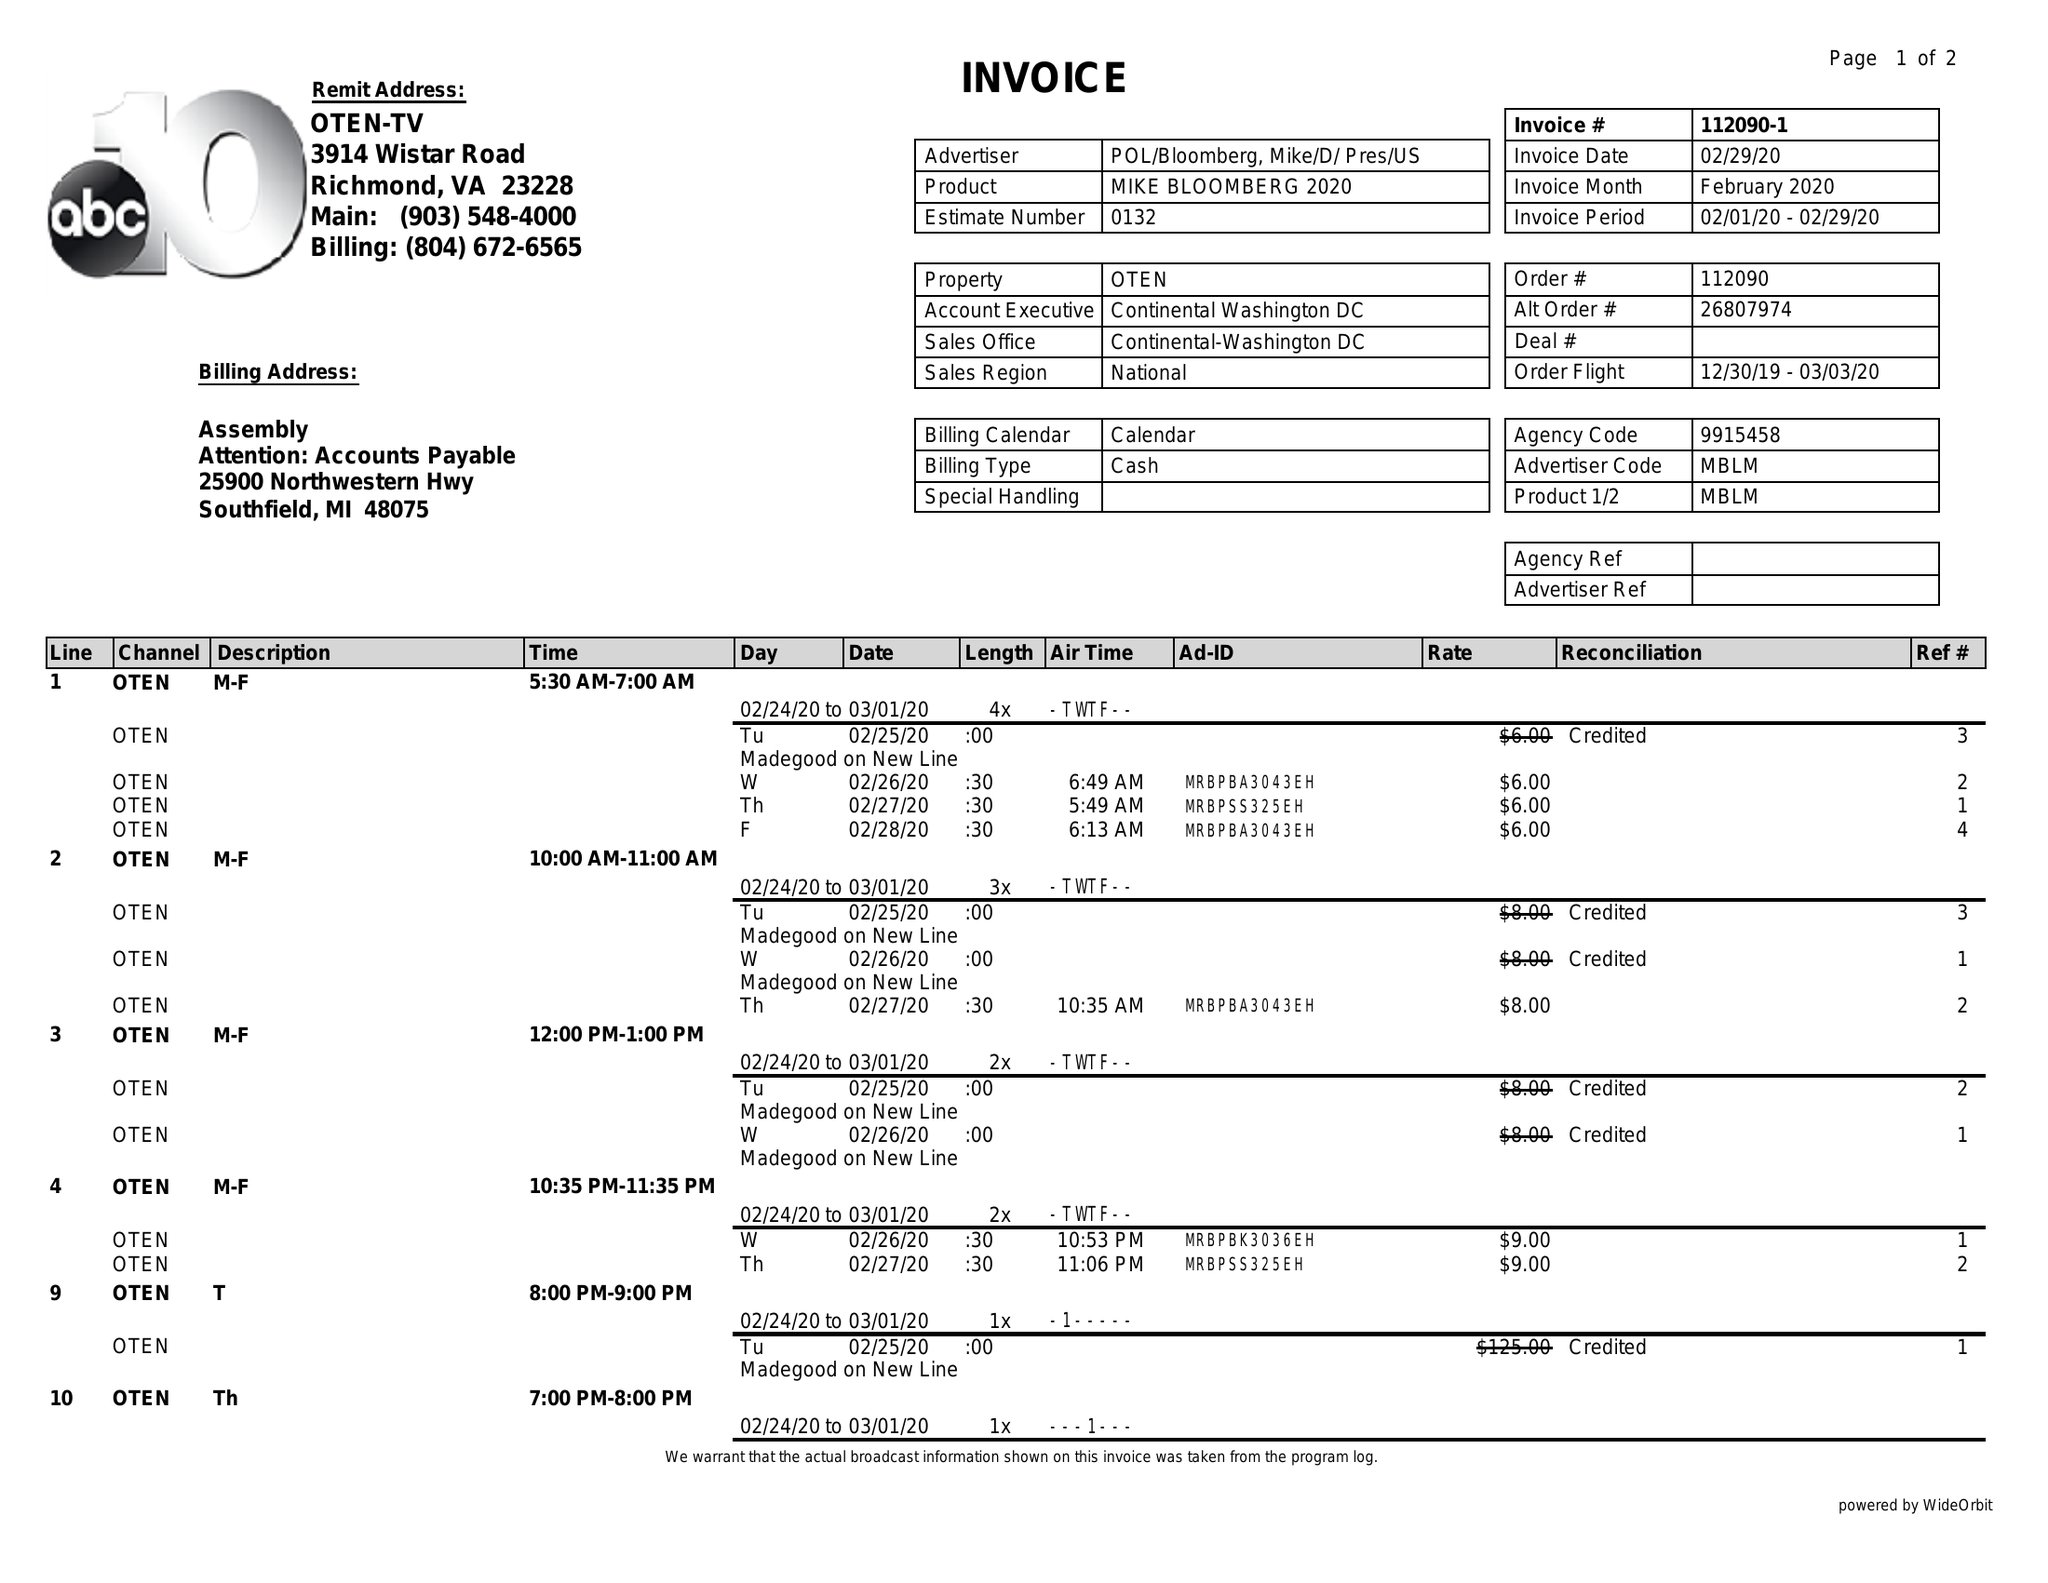What is the value for the gross_amount?
Answer the question using a single word or phrase. 194.00 